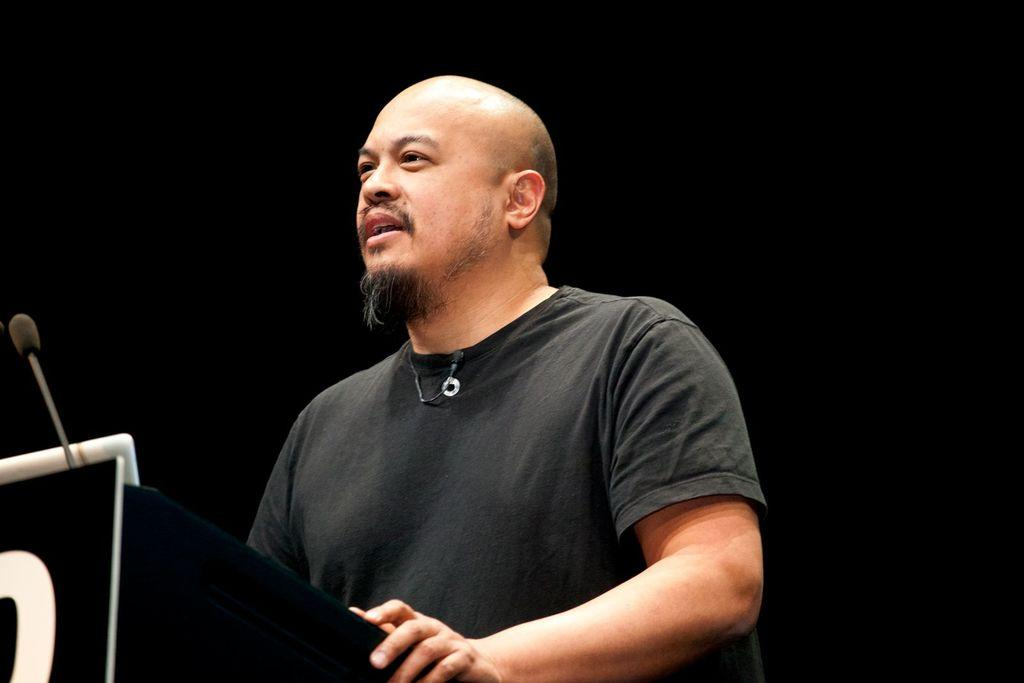Who is present in the image? There is a man in the image. What object can be seen in front of the man? There is a podium in the image. What device is the man likely to use for speaking? There is a microphone in the image. What can be inferred about the lighting conditions in the image? The background of the image is dark. What direction is the man facing in the image? The provided facts do not specify the direction the man is facing. How many trucks are visible in the image? There are no trucks present in the image. 